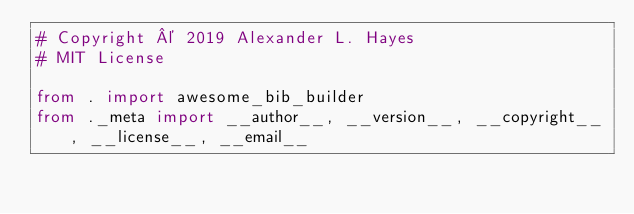Convert code to text. <code><loc_0><loc_0><loc_500><loc_500><_Python_># Copyright © 2019 Alexander L. Hayes
# MIT License

from . import awesome_bib_builder
from ._meta import __author__, __version__, __copyright__, __license__, __email__
</code> 